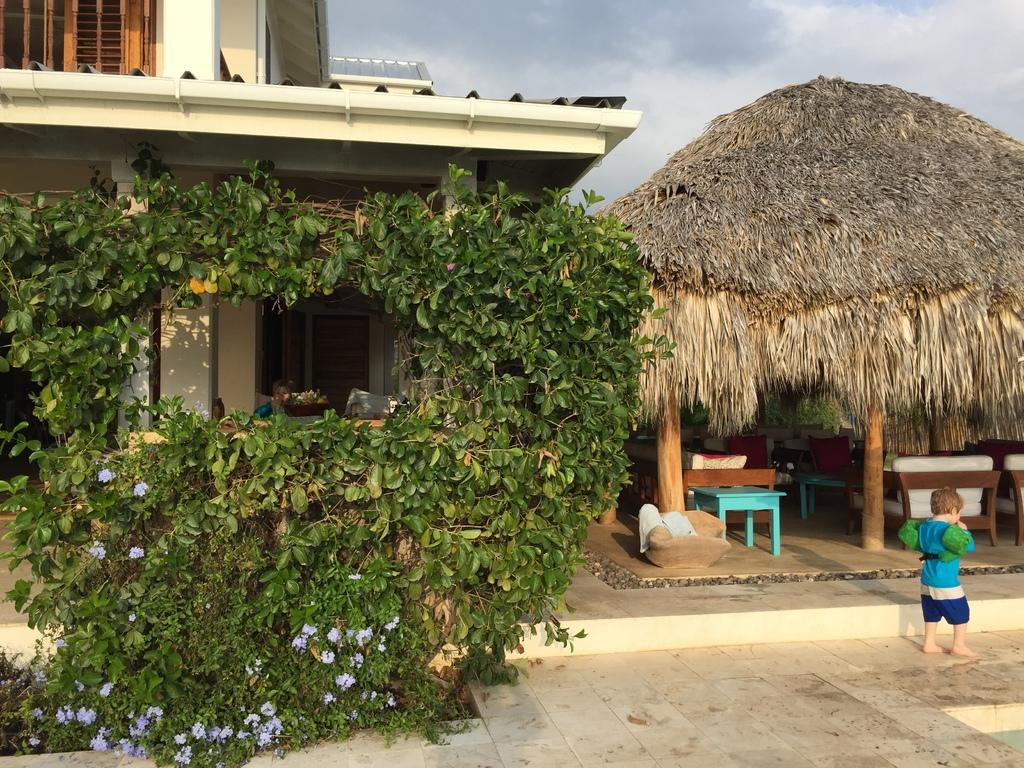What type of structures are present in the image? There is a building and a hut in the image. What is located under the hut? There is a table under the hut. What type of natural elements can be seen in the image? There are trees and plants in the image. Who is present in the image? There is a kid in the image. Can you tell me how many houses are visible in the image? There is no house present in the image; only a building and a hut are visible. Are there any dinosaurs visible in the image? There are no dinosaurs present in the image. 